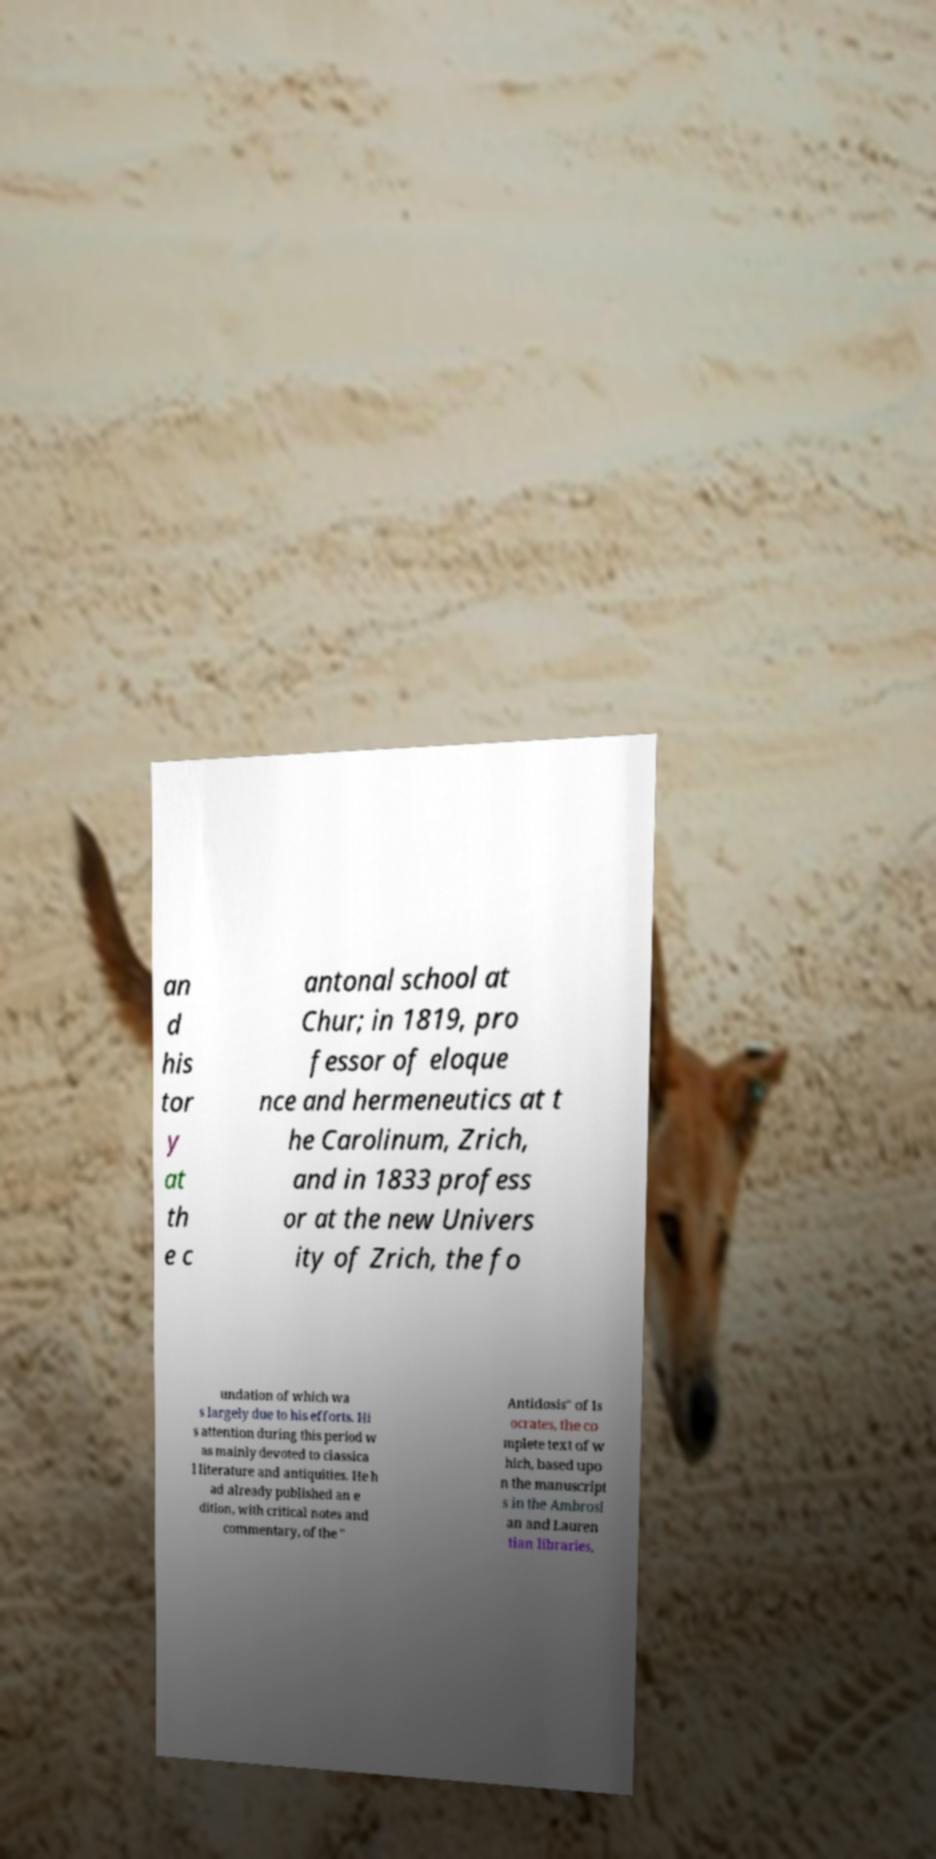Please read and relay the text visible in this image. What does it say? an d his tor y at th e c antonal school at Chur; in 1819, pro fessor of eloque nce and hermeneutics at t he Carolinum, Zrich, and in 1833 profess or at the new Univers ity of Zrich, the fo undation of which wa s largely due to his efforts. Hi s attention during this period w as mainly devoted to classica l literature and antiquities. He h ad already published an e dition, with critical notes and commentary, of the " Antidosis" of Is ocrates, the co mplete text of w hich, based upo n the manuscript s in the Ambrosi an and Lauren tian libraries, 